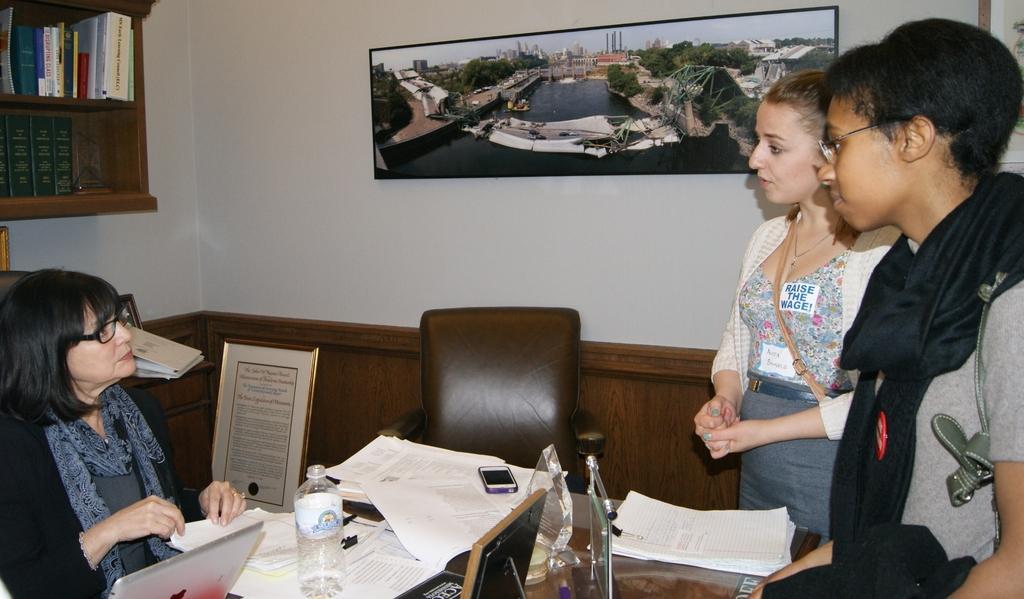Could you give a brief overview of what you see in this image? On the background we can see a photo frame and a cupboard , books inside it over a wall. Here we can see two persons standing in front of a table and talking to this women who is sitting on a chair and on the table we can see a mike, papers, mobile phone, bottle, laptop. This is an empty chair and here we can see a frame. 